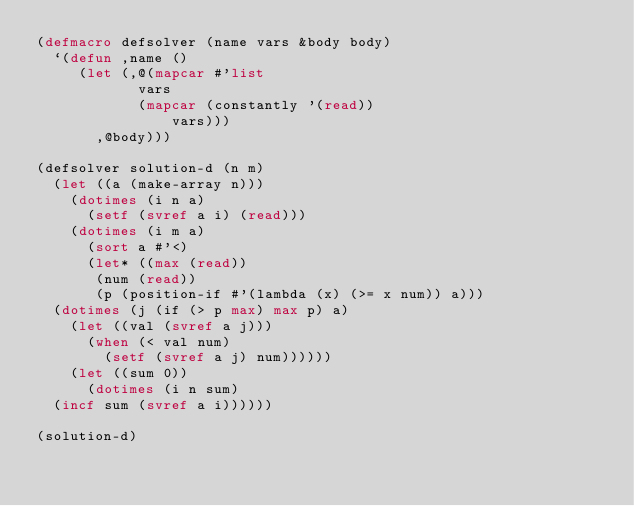Convert code to text. <code><loc_0><loc_0><loc_500><loc_500><_Lisp_>(defmacro defsolver (name vars &body body)
  `(defun ,name ()
     (let (,@(mapcar #'list
            vars
            (mapcar (constantly '(read))
                vars)))
       ,@body)))

(defsolver solution-d (n m)
  (let ((a (make-array n)))
    (dotimes (i n a)
      (setf (svref a i) (read)))
    (dotimes (i m a)
      (sort a #'<)
      (let* ((max (read))
	     (num (read))
	     (p (position-if #'(lambda (x) (>= x num)) a)))
	(dotimes (j (if (> p max) max p) a)
	  (let ((val (svref a j)))
	    (when (< val num)
	      (setf (svref a j) num))))))
    (let ((sum 0))
      (dotimes (i n sum)
	(incf sum (svref a i))))))

(solution-d)</code> 